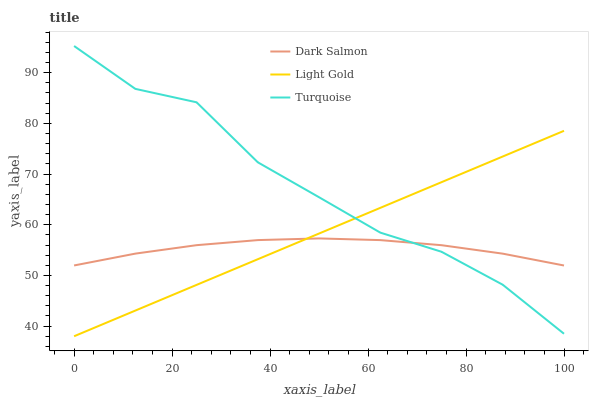Does Dark Salmon have the minimum area under the curve?
Answer yes or no. Yes. Does Turquoise have the maximum area under the curve?
Answer yes or no. Yes. Does Light Gold have the minimum area under the curve?
Answer yes or no. No. Does Light Gold have the maximum area under the curve?
Answer yes or no. No. Is Light Gold the smoothest?
Answer yes or no. Yes. Is Turquoise the roughest?
Answer yes or no. Yes. Is Dark Salmon the smoothest?
Answer yes or no. No. Is Dark Salmon the roughest?
Answer yes or no. No. Does Light Gold have the lowest value?
Answer yes or no. Yes. Does Dark Salmon have the lowest value?
Answer yes or no. No. Does Turquoise have the highest value?
Answer yes or no. Yes. Does Light Gold have the highest value?
Answer yes or no. No. Does Light Gold intersect Turquoise?
Answer yes or no. Yes. Is Light Gold less than Turquoise?
Answer yes or no. No. Is Light Gold greater than Turquoise?
Answer yes or no. No. 